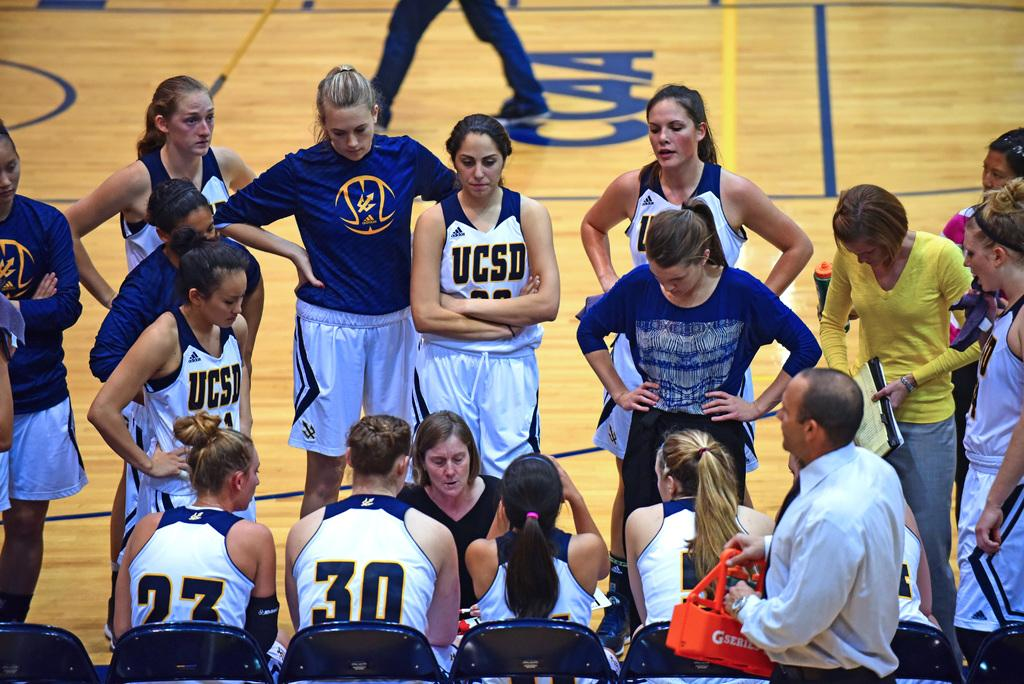Provide a one-sentence caption for the provided image. Basketball player wearing a jersey which says UCSD. 